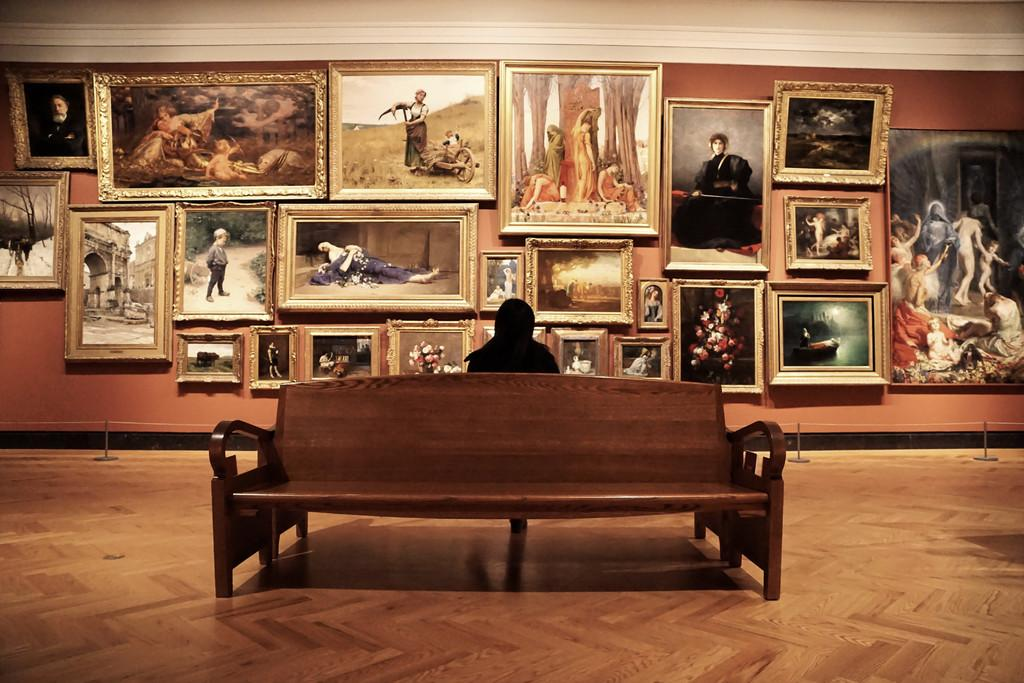What is the person in the image doing? The person is sitting on a bench in the image. What can be seen on the wall in the image? There are photo frames on the wall in the image. What is depicted in the photo frames? The photo frames contain images of a kid, a woman, and other persons. What type of crack can be seen in the image? There is no crack present in the image. Can you describe the harbor in the image? There is no harbor present in the image. 